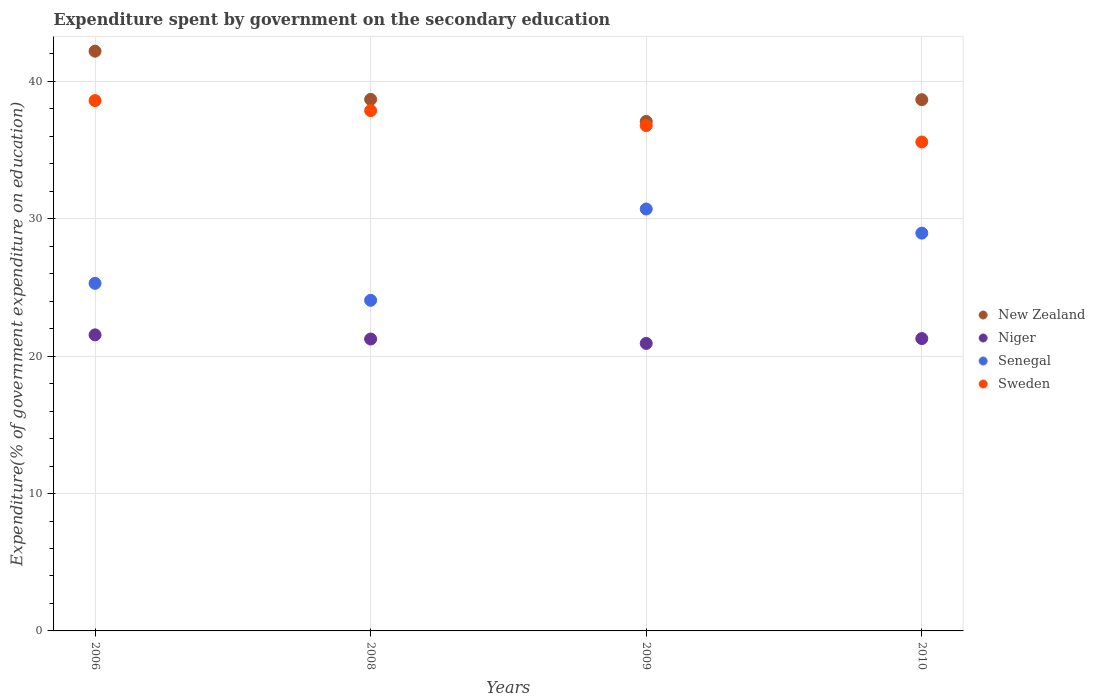How many different coloured dotlines are there?
Your answer should be very brief. 4. Is the number of dotlines equal to the number of legend labels?
Give a very brief answer. Yes. What is the expenditure spent by government on the secondary education in Niger in 2006?
Offer a very short reply. 21.55. Across all years, what is the maximum expenditure spent by government on the secondary education in Senegal?
Offer a very short reply. 30.71. Across all years, what is the minimum expenditure spent by government on the secondary education in Sweden?
Provide a succinct answer. 35.59. In which year was the expenditure spent by government on the secondary education in Senegal maximum?
Your answer should be compact. 2009. What is the total expenditure spent by government on the secondary education in Sweden in the graph?
Your answer should be very brief. 148.84. What is the difference between the expenditure spent by government on the secondary education in Niger in 2006 and that in 2010?
Provide a short and direct response. 0.27. What is the difference between the expenditure spent by government on the secondary education in Sweden in 2008 and the expenditure spent by government on the secondary education in Senegal in 2010?
Provide a succinct answer. 8.92. What is the average expenditure spent by government on the secondary education in Niger per year?
Keep it short and to the point. 21.25. In the year 2009, what is the difference between the expenditure spent by government on the secondary education in New Zealand and expenditure spent by government on the secondary education in Senegal?
Make the answer very short. 6.38. In how many years, is the expenditure spent by government on the secondary education in New Zealand greater than 6 %?
Provide a short and direct response. 4. What is the ratio of the expenditure spent by government on the secondary education in Sweden in 2008 to that in 2010?
Offer a terse response. 1.06. What is the difference between the highest and the second highest expenditure spent by government on the secondary education in New Zealand?
Ensure brevity in your answer.  3.51. What is the difference between the highest and the lowest expenditure spent by government on the secondary education in New Zealand?
Make the answer very short. 5.11. In how many years, is the expenditure spent by government on the secondary education in Sweden greater than the average expenditure spent by government on the secondary education in Sweden taken over all years?
Your response must be concise. 2. Is the sum of the expenditure spent by government on the secondary education in Sweden in 2008 and 2010 greater than the maximum expenditure spent by government on the secondary education in Niger across all years?
Provide a short and direct response. Yes. Is the expenditure spent by government on the secondary education in Senegal strictly less than the expenditure spent by government on the secondary education in Sweden over the years?
Make the answer very short. Yes. How many dotlines are there?
Offer a terse response. 4. Are the values on the major ticks of Y-axis written in scientific E-notation?
Provide a short and direct response. No. Does the graph contain any zero values?
Ensure brevity in your answer.  No. How many legend labels are there?
Your answer should be very brief. 4. How are the legend labels stacked?
Offer a terse response. Vertical. What is the title of the graph?
Keep it short and to the point. Expenditure spent by government on the secondary education. Does "Indonesia" appear as one of the legend labels in the graph?
Offer a terse response. No. What is the label or title of the Y-axis?
Offer a terse response. Expenditure(% of government expenditure on education). What is the Expenditure(% of government expenditure on education) in New Zealand in 2006?
Your answer should be very brief. 42.2. What is the Expenditure(% of government expenditure on education) in Niger in 2006?
Your answer should be compact. 21.55. What is the Expenditure(% of government expenditure on education) of Senegal in 2006?
Provide a short and direct response. 25.3. What is the Expenditure(% of government expenditure on education) of Sweden in 2006?
Your answer should be very brief. 38.6. What is the Expenditure(% of government expenditure on education) of New Zealand in 2008?
Your answer should be very brief. 38.69. What is the Expenditure(% of government expenditure on education) of Niger in 2008?
Make the answer very short. 21.25. What is the Expenditure(% of government expenditure on education) of Senegal in 2008?
Ensure brevity in your answer.  24.06. What is the Expenditure(% of government expenditure on education) in Sweden in 2008?
Keep it short and to the point. 37.87. What is the Expenditure(% of government expenditure on education) in New Zealand in 2009?
Your answer should be compact. 37.09. What is the Expenditure(% of government expenditure on education) of Niger in 2009?
Make the answer very short. 20.93. What is the Expenditure(% of government expenditure on education) in Senegal in 2009?
Ensure brevity in your answer.  30.71. What is the Expenditure(% of government expenditure on education) in Sweden in 2009?
Your response must be concise. 36.78. What is the Expenditure(% of government expenditure on education) in New Zealand in 2010?
Your answer should be very brief. 38.67. What is the Expenditure(% of government expenditure on education) of Niger in 2010?
Make the answer very short. 21.28. What is the Expenditure(% of government expenditure on education) of Senegal in 2010?
Offer a very short reply. 28.95. What is the Expenditure(% of government expenditure on education) in Sweden in 2010?
Offer a terse response. 35.59. Across all years, what is the maximum Expenditure(% of government expenditure on education) of New Zealand?
Offer a very short reply. 42.2. Across all years, what is the maximum Expenditure(% of government expenditure on education) of Niger?
Your answer should be compact. 21.55. Across all years, what is the maximum Expenditure(% of government expenditure on education) in Senegal?
Give a very brief answer. 30.71. Across all years, what is the maximum Expenditure(% of government expenditure on education) in Sweden?
Your answer should be very brief. 38.6. Across all years, what is the minimum Expenditure(% of government expenditure on education) in New Zealand?
Offer a terse response. 37.09. Across all years, what is the minimum Expenditure(% of government expenditure on education) in Niger?
Your answer should be compact. 20.93. Across all years, what is the minimum Expenditure(% of government expenditure on education) of Senegal?
Your answer should be compact. 24.06. Across all years, what is the minimum Expenditure(% of government expenditure on education) in Sweden?
Provide a succinct answer. 35.59. What is the total Expenditure(% of government expenditure on education) of New Zealand in the graph?
Your response must be concise. 156.64. What is the total Expenditure(% of government expenditure on education) of Niger in the graph?
Offer a very short reply. 85. What is the total Expenditure(% of government expenditure on education) in Senegal in the graph?
Provide a short and direct response. 109.03. What is the total Expenditure(% of government expenditure on education) of Sweden in the graph?
Your answer should be very brief. 148.84. What is the difference between the Expenditure(% of government expenditure on education) of New Zealand in 2006 and that in 2008?
Your answer should be very brief. 3.51. What is the difference between the Expenditure(% of government expenditure on education) of Niger in 2006 and that in 2008?
Make the answer very short. 0.3. What is the difference between the Expenditure(% of government expenditure on education) in Senegal in 2006 and that in 2008?
Your response must be concise. 1.24. What is the difference between the Expenditure(% of government expenditure on education) of Sweden in 2006 and that in 2008?
Your answer should be compact. 0.73. What is the difference between the Expenditure(% of government expenditure on education) in New Zealand in 2006 and that in 2009?
Provide a succinct answer. 5.11. What is the difference between the Expenditure(% of government expenditure on education) in Niger in 2006 and that in 2009?
Give a very brief answer. 0.62. What is the difference between the Expenditure(% of government expenditure on education) in Senegal in 2006 and that in 2009?
Your answer should be very brief. -5.41. What is the difference between the Expenditure(% of government expenditure on education) of Sweden in 2006 and that in 2009?
Your answer should be very brief. 1.82. What is the difference between the Expenditure(% of government expenditure on education) in New Zealand in 2006 and that in 2010?
Your response must be concise. 3.53. What is the difference between the Expenditure(% of government expenditure on education) of Niger in 2006 and that in 2010?
Ensure brevity in your answer.  0.27. What is the difference between the Expenditure(% of government expenditure on education) of Senegal in 2006 and that in 2010?
Offer a very short reply. -3.65. What is the difference between the Expenditure(% of government expenditure on education) in Sweden in 2006 and that in 2010?
Offer a very short reply. 3.01. What is the difference between the Expenditure(% of government expenditure on education) of New Zealand in 2008 and that in 2009?
Provide a short and direct response. 1.6. What is the difference between the Expenditure(% of government expenditure on education) of Niger in 2008 and that in 2009?
Provide a succinct answer. 0.32. What is the difference between the Expenditure(% of government expenditure on education) in Senegal in 2008 and that in 2009?
Provide a short and direct response. -6.65. What is the difference between the Expenditure(% of government expenditure on education) in Sweden in 2008 and that in 2009?
Offer a very short reply. 1.09. What is the difference between the Expenditure(% of government expenditure on education) in New Zealand in 2008 and that in 2010?
Keep it short and to the point. 0.02. What is the difference between the Expenditure(% of government expenditure on education) of Niger in 2008 and that in 2010?
Provide a short and direct response. -0.03. What is the difference between the Expenditure(% of government expenditure on education) in Senegal in 2008 and that in 2010?
Offer a very short reply. -4.89. What is the difference between the Expenditure(% of government expenditure on education) of Sweden in 2008 and that in 2010?
Offer a terse response. 2.28. What is the difference between the Expenditure(% of government expenditure on education) in New Zealand in 2009 and that in 2010?
Make the answer very short. -1.58. What is the difference between the Expenditure(% of government expenditure on education) in Niger in 2009 and that in 2010?
Your answer should be very brief. -0.35. What is the difference between the Expenditure(% of government expenditure on education) of Senegal in 2009 and that in 2010?
Make the answer very short. 1.76. What is the difference between the Expenditure(% of government expenditure on education) of Sweden in 2009 and that in 2010?
Your answer should be compact. 1.2. What is the difference between the Expenditure(% of government expenditure on education) of New Zealand in 2006 and the Expenditure(% of government expenditure on education) of Niger in 2008?
Offer a very short reply. 20.95. What is the difference between the Expenditure(% of government expenditure on education) in New Zealand in 2006 and the Expenditure(% of government expenditure on education) in Senegal in 2008?
Your response must be concise. 18.13. What is the difference between the Expenditure(% of government expenditure on education) in New Zealand in 2006 and the Expenditure(% of government expenditure on education) in Sweden in 2008?
Your answer should be very brief. 4.33. What is the difference between the Expenditure(% of government expenditure on education) in Niger in 2006 and the Expenditure(% of government expenditure on education) in Senegal in 2008?
Give a very brief answer. -2.52. What is the difference between the Expenditure(% of government expenditure on education) in Niger in 2006 and the Expenditure(% of government expenditure on education) in Sweden in 2008?
Your response must be concise. -16.32. What is the difference between the Expenditure(% of government expenditure on education) of Senegal in 2006 and the Expenditure(% of government expenditure on education) of Sweden in 2008?
Your answer should be very brief. -12.57. What is the difference between the Expenditure(% of government expenditure on education) of New Zealand in 2006 and the Expenditure(% of government expenditure on education) of Niger in 2009?
Your answer should be compact. 21.27. What is the difference between the Expenditure(% of government expenditure on education) in New Zealand in 2006 and the Expenditure(% of government expenditure on education) in Senegal in 2009?
Offer a terse response. 11.49. What is the difference between the Expenditure(% of government expenditure on education) of New Zealand in 2006 and the Expenditure(% of government expenditure on education) of Sweden in 2009?
Offer a very short reply. 5.41. What is the difference between the Expenditure(% of government expenditure on education) of Niger in 2006 and the Expenditure(% of government expenditure on education) of Senegal in 2009?
Keep it short and to the point. -9.16. What is the difference between the Expenditure(% of government expenditure on education) of Niger in 2006 and the Expenditure(% of government expenditure on education) of Sweden in 2009?
Offer a terse response. -15.23. What is the difference between the Expenditure(% of government expenditure on education) of Senegal in 2006 and the Expenditure(% of government expenditure on education) of Sweden in 2009?
Give a very brief answer. -11.48. What is the difference between the Expenditure(% of government expenditure on education) of New Zealand in 2006 and the Expenditure(% of government expenditure on education) of Niger in 2010?
Give a very brief answer. 20.92. What is the difference between the Expenditure(% of government expenditure on education) of New Zealand in 2006 and the Expenditure(% of government expenditure on education) of Senegal in 2010?
Ensure brevity in your answer.  13.24. What is the difference between the Expenditure(% of government expenditure on education) in New Zealand in 2006 and the Expenditure(% of government expenditure on education) in Sweden in 2010?
Offer a terse response. 6.61. What is the difference between the Expenditure(% of government expenditure on education) in Niger in 2006 and the Expenditure(% of government expenditure on education) in Senegal in 2010?
Your answer should be very brief. -7.4. What is the difference between the Expenditure(% of government expenditure on education) of Niger in 2006 and the Expenditure(% of government expenditure on education) of Sweden in 2010?
Your answer should be very brief. -14.04. What is the difference between the Expenditure(% of government expenditure on education) of Senegal in 2006 and the Expenditure(% of government expenditure on education) of Sweden in 2010?
Ensure brevity in your answer.  -10.29. What is the difference between the Expenditure(% of government expenditure on education) in New Zealand in 2008 and the Expenditure(% of government expenditure on education) in Niger in 2009?
Keep it short and to the point. 17.76. What is the difference between the Expenditure(% of government expenditure on education) of New Zealand in 2008 and the Expenditure(% of government expenditure on education) of Senegal in 2009?
Your answer should be very brief. 7.98. What is the difference between the Expenditure(% of government expenditure on education) in New Zealand in 2008 and the Expenditure(% of government expenditure on education) in Sweden in 2009?
Make the answer very short. 1.91. What is the difference between the Expenditure(% of government expenditure on education) of Niger in 2008 and the Expenditure(% of government expenditure on education) of Senegal in 2009?
Your response must be concise. -9.46. What is the difference between the Expenditure(% of government expenditure on education) of Niger in 2008 and the Expenditure(% of government expenditure on education) of Sweden in 2009?
Ensure brevity in your answer.  -15.54. What is the difference between the Expenditure(% of government expenditure on education) in Senegal in 2008 and the Expenditure(% of government expenditure on education) in Sweden in 2009?
Keep it short and to the point. -12.72. What is the difference between the Expenditure(% of government expenditure on education) in New Zealand in 2008 and the Expenditure(% of government expenditure on education) in Niger in 2010?
Ensure brevity in your answer.  17.41. What is the difference between the Expenditure(% of government expenditure on education) of New Zealand in 2008 and the Expenditure(% of government expenditure on education) of Senegal in 2010?
Ensure brevity in your answer.  9.74. What is the difference between the Expenditure(% of government expenditure on education) of New Zealand in 2008 and the Expenditure(% of government expenditure on education) of Sweden in 2010?
Keep it short and to the point. 3.1. What is the difference between the Expenditure(% of government expenditure on education) of Niger in 2008 and the Expenditure(% of government expenditure on education) of Senegal in 2010?
Provide a succinct answer. -7.71. What is the difference between the Expenditure(% of government expenditure on education) in Niger in 2008 and the Expenditure(% of government expenditure on education) in Sweden in 2010?
Ensure brevity in your answer.  -14.34. What is the difference between the Expenditure(% of government expenditure on education) of Senegal in 2008 and the Expenditure(% of government expenditure on education) of Sweden in 2010?
Your answer should be compact. -11.52. What is the difference between the Expenditure(% of government expenditure on education) of New Zealand in 2009 and the Expenditure(% of government expenditure on education) of Niger in 2010?
Provide a short and direct response. 15.81. What is the difference between the Expenditure(% of government expenditure on education) of New Zealand in 2009 and the Expenditure(% of government expenditure on education) of Senegal in 2010?
Give a very brief answer. 8.13. What is the difference between the Expenditure(% of government expenditure on education) in New Zealand in 2009 and the Expenditure(% of government expenditure on education) in Sweden in 2010?
Give a very brief answer. 1.5. What is the difference between the Expenditure(% of government expenditure on education) of Niger in 2009 and the Expenditure(% of government expenditure on education) of Senegal in 2010?
Provide a succinct answer. -8.03. What is the difference between the Expenditure(% of government expenditure on education) in Niger in 2009 and the Expenditure(% of government expenditure on education) in Sweden in 2010?
Give a very brief answer. -14.66. What is the difference between the Expenditure(% of government expenditure on education) of Senegal in 2009 and the Expenditure(% of government expenditure on education) of Sweden in 2010?
Ensure brevity in your answer.  -4.88. What is the average Expenditure(% of government expenditure on education) in New Zealand per year?
Provide a succinct answer. 39.16. What is the average Expenditure(% of government expenditure on education) of Niger per year?
Make the answer very short. 21.25. What is the average Expenditure(% of government expenditure on education) in Senegal per year?
Ensure brevity in your answer.  27.26. What is the average Expenditure(% of government expenditure on education) of Sweden per year?
Your response must be concise. 37.21. In the year 2006, what is the difference between the Expenditure(% of government expenditure on education) in New Zealand and Expenditure(% of government expenditure on education) in Niger?
Offer a very short reply. 20.65. In the year 2006, what is the difference between the Expenditure(% of government expenditure on education) of New Zealand and Expenditure(% of government expenditure on education) of Senegal?
Provide a short and direct response. 16.9. In the year 2006, what is the difference between the Expenditure(% of government expenditure on education) of New Zealand and Expenditure(% of government expenditure on education) of Sweden?
Your answer should be compact. 3.6. In the year 2006, what is the difference between the Expenditure(% of government expenditure on education) of Niger and Expenditure(% of government expenditure on education) of Senegal?
Give a very brief answer. -3.75. In the year 2006, what is the difference between the Expenditure(% of government expenditure on education) of Niger and Expenditure(% of government expenditure on education) of Sweden?
Ensure brevity in your answer.  -17.05. In the year 2006, what is the difference between the Expenditure(% of government expenditure on education) of Senegal and Expenditure(% of government expenditure on education) of Sweden?
Provide a short and direct response. -13.3. In the year 2008, what is the difference between the Expenditure(% of government expenditure on education) in New Zealand and Expenditure(% of government expenditure on education) in Niger?
Your answer should be compact. 17.44. In the year 2008, what is the difference between the Expenditure(% of government expenditure on education) in New Zealand and Expenditure(% of government expenditure on education) in Senegal?
Offer a terse response. 14.62. In the year 2008, what is the difference between the Expenditure(% of government expenditure on education) in New Zealand and Expenditure(% of government expenditure on education) in Sweden?
Your answer should be very brief. 0.82. In the year 2008, what is the difference between the Expenditure(% of government expenditure on education) of Niger and Expenditure(% of government expenditure on education) of Senegal?
Your response must be concise. -2.82. In the year 2008, what is the difference between the Expenditure(% of government expenditure on education) of Niger and Expenditure(% of government expenditure on education) of Sweden?
Give a very brief answer. -16.62. In the year 2008, what is the difference between the Expenditure(% of government expenditure on education) of Senegal and Expenditure(% of government expenditure on education) of Sweden?
Keep it short and to the point. -13.81. In the year 2009, what is the difference between the Expenditure(% of government expenditure on education) of New Zealand and Expenditure(% of government expenditure on education) of Niger?
Make the answer very short. 16.16. In the year 2009, what is the difference between the Expenditure(% of government expenditure on education) of New Zealand and Expenditure(% of government expenditure on education) of Senegal?
Provide a short and direct response. 6.38. In the year 2009, what is the difference between the Expenditure(% of government expenditure on education) in New Zealand and Expenditure(% of government expenditure on education) in Sweden?
Offer a terse response. 0.3. In the year 2009, what is the difference between the Expenditure(% of government expenditure on education) of Niger and Expenditure(% of government expenditure on education) of Senegal?
Your answer should be compact. -9.78. In the year 2009, what is the difference between the Expenditure(% of government expenditure on education) of Niger and Expenditure(% of government expenditure on education) of Sweden?
Offer a terse response. -15.86. In the year 2009, what is the difference between the Expenditure(% of government expenditure on education) in Senegal and Expenditure(% of government expenditure on education) in Sweden?
Your response must be concise. -6.07. In the year 2010, what is the difference between the Expenditure(% of government expenditure on education) of New Zealand and Expenditure(% of government expenditure on education) of Niger?
Provide a succinct answer. 17.39. In the year 2010, what is the difference between the Expenditure(% of government expenditure on education) in New Zealand and Expenditure(% of government expenditure on education) in Senegal?
Your answer should be very brief. 9.71. In the year 2010, what is the difference between the Expenditure(% of government expenditure on education) of New Zealand and Expenditure(% of government expenditure on education) of Sweden?
Give a very brief answer. 3.08. In the year 2010, what is the difference between the Expenditure(% of government expenditure on education) in Niger and Expenditure(% of government expenditure on education) in Senegal?
Give a very brief answer. -7.67. In the year 2010, what is the difference between the Expenditure(% of government expenditure on education) in Niger and Expenditure(% of government expenditure on education) in Sweden?
Your response must be concise. -14.31. In the year 2010, what is the difference between the Expenditure(% of government expenditure on education) in Senegal and Expenditure(% of government expenditure on education) in Sweden?
Offer a terse response. -6.63. What is the ratio of the Expenditure(% of government expenditure on education) in New Zealand in 2006 to that in 2008?
Offer a terse response. 1.09. What is the ratio of the Expenditure(% of government expenditure on education) in Niger in 2006 to that in 2008?
Your response must be concise. 1.01. What is the ratio of the Expenditure(% of government expenditure on education) of Senegal in 2006 to that in 2008?
Your answer should be compact. 1.05. What is the ratio of the Expenditure(% of government expenditure on education) in Sweden in 2006 to that in 2008?
Ensure brevity in your answer.  1.02. What is the ratio of the Expenditure(% of government expenditure on education) of New Zealand in 2006 to that in 2009?
Make the answer very short. 1.14. What is the ratio of the Expenditure(% of government expenditure on education) in Niger in 2006 to that in 2009?
Keep it short and to the point. 1.03. What is the ratio of the Expenditure(% of government expenditure on education) in Senegal in 2006 to that in 2009?
Ensure brevity in your answer.  0.82. What is the ratio of the Expenditure(% of government expenditure on education) of Sweden in 2006 to that in 2009?
Provide a short and direct response. 1.05. What is the ratio of the Expenditure(% of government expenditure on education) in New Zealand in 2006 to that in 2010?
Give a very brief answer. 1.09. What is the ratio of the Expenditure(% of government expenditure on education) in Niger in 2006 to that in 2010?
Make the answer very short. 1.01. What is the ratio of the Expenditure(% of government expenditure on education) of Senegal in 2006 to that in 2010?
Provide a succinct answer. 0.87. What is the ratio of the Expenditure(% of government expenditure on education) of Sweden in 2006 to that in 2010?
Give a very brief answer. 1.08. What is the ratio of the Expenditure(% of government expenditure on education) in New Zealand in 2008 to that in 2009?
Provide a succinct answer. 1.04. What is the ratio of the Expenditure(% of government expenditure on education) in Niger in 2008 to that in 2009?
Your response must be concise. 1.02. What is the ratio of the Expenditure(% of government expenditure on education) in Senegal in 2008 to that in 2009?
Make the answer very short. 0.78. What is the ratio of the Expenditure(% of government expenditure on education) of Sweden in 2008 to that in 2009?
Your response must be concise. 1.03. What is the ratio of the Expenditure(% of government expenditure on education) in New Zealand in 2008 to that in 2010?
Ensure brevity in your answer.  1. What is the ratio of the Expenditure(% of government expenditure on education) in Senegal in 2008 to that in 2010?
Make the answer very short. 0.83. What is the ratio of the Expenditure(% of government expenditure on education) of Sweden in 2008 to that in 2010?
Keep it short and to the point. 1.06. What is the ratio of the Expenditure(% of government expenditure on education) of New Zealand in 2009 to that in 2010?
Make the answer very short. 0.96. What is the ratio of the Expenditure(% of government expenditure on education) of Niger in 2009 to that in 2010?
Ensure brevity in your answer.  0.98. What is the ratio of the Expenditure(% of government expenditure on education) in Senegal in 2009 to that in 2010?
Provide a succinct answer. 1.06. What is the ratio of the Expenditure(% of government expenditure on education) in Sweden in 2009 to that in 2010?
Provide a succinct answer. 1.03. What is the difference between the highest and the second highest Expenditure(% of government expenditure on education) in New Zealand?
Your answer should be very brief. 3.51. What is the difference between the highest and the second highest Expenditure(% of government expenditure on education) of Niger?
Offer a terse response. 0.27. What is the difference between the highest and the second highest Expenditure(% of government expenditure on education) of Senegal?
Make the answer very short. 1.76. What is the difference between the highest and the second highest Expenditure(% of government expenditure on education) in Sweden?
Your answer should be very brief. 0.73. What is the difference between the highest and the lowest Expenditure(% of government expenditure on education) of New Zealand?
Offer a very short reply. 5.11. What is the difference between the highest and the lowest Expenditure(% of government expenditure on education) in Niger?
Provide a short and direct response. 0.62. What is the difference between the highest and the lowest Expenditure(% of government expenditure on education) of Senegal?
Provide a succinct answer. 6.65. What is the difference between the highest and the lowest Expenditure(% of government expenditure on education) in Sweden?
Keep it short and to the point. 3.01. 